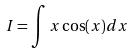Convert formula to latex. <formula><loc_0><loc_0><loc_500><loc_500>I = \int x \cos ( x ) d x</formula> 